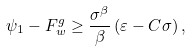Convert formula to latex. <formula><loc_0><loc_0><loc_500><loc_500>\psi _ { 1 } - F _ { w } ^ { g } \geq \frac { \sigma ^ { \beta } } { \beta } \left ( \varepsilon - C \sigma \right ) ,</formula> 